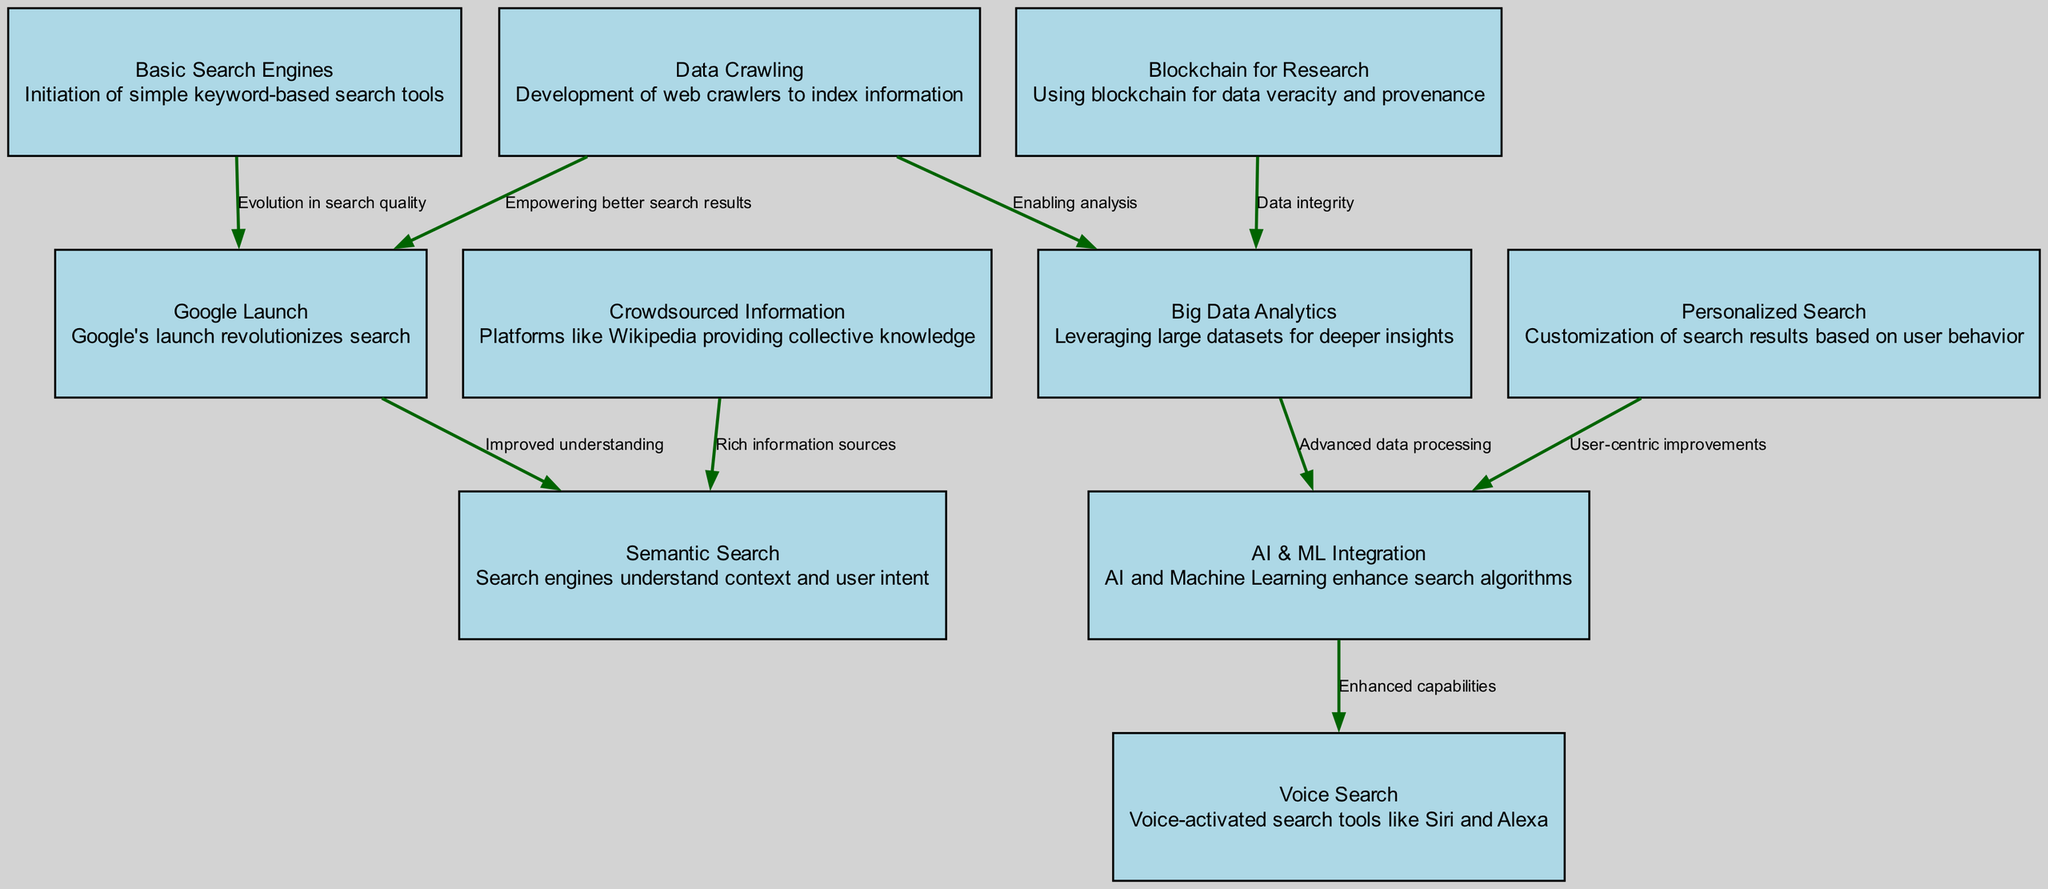What does the label for "AI & ML Integration" describe? The label for "AI & ML Integration" describes how AI and Machine Learning enhance search algorithms.
Answer: AI and Machine Learning enhance search algorithms How many nodes are present in the diagram? By counting the items listed under the "nodes" section, we find there are 10 distinct nodes present in the diagram.
Answer: 10 What is the relationship between "Data Crawling" and "Big Data Analytics"? "Data Crawling" enables analysis and provides the foundation for "Big Data Analytics" to leverage large datasets.
Answer: Enabling analysis Which node precedes "Voice Search" in the diagram? "AI & ML Integration" directly connects to "Voice Search," indicating it precedes this node in the diagram.
Answer: AI & ML Integration How does "Google Launch" relate to "Semantic Search"? "Google Launch" improves understanding, which enhances the capabilities related to "Semantic Search" in the system of research tools evolution.
Answer: Improved understanding What type of information is provided by "Crowdsourced Information"? "Crowdsourced Information" is associated with platforms like Wikipedia that provide collective knowledge, enriching the informational landscape.
Answer: Collective knowledge What concept does "Blockchain for Research" contribute to in the diagram? "Blockchain for Research" contributes to ensuring data integrity, emphasizing the importance of veracity and provenance of data being researched.
Answer: Data integrity Which node has the label indicating "Customization of search results based on user behavior"? The node labeled "Personalized Search" indicates customization of search results based on user behavior.
Answer: Personalized Search What developmental stage is indicated before the "Google Launch"? Before "Google Launch," the diagram indicates the stage of "Basic Search Engines," showcasing the evolution of search tools.
Answer: Basic Search Engines What does "Big Data Analytics" get enhanced by according to the diagram? "Big Data Analytics" is enhanced by the integration of AI and machine learning techniques, allowing for deeper insights into large datasets.
Answer: AI and ML Integration 